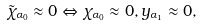<formula> <loc_0><loc_0><loc_500><loc_500>\tilde { \chi } _ { \alpha _ { 0 } } \approx 0 \Leftrightarrow \chi _ { \alpha _ { 0 } } \approx 0 , y _ { \alpha _ { 1 } } \approx 0 ,</formula> 